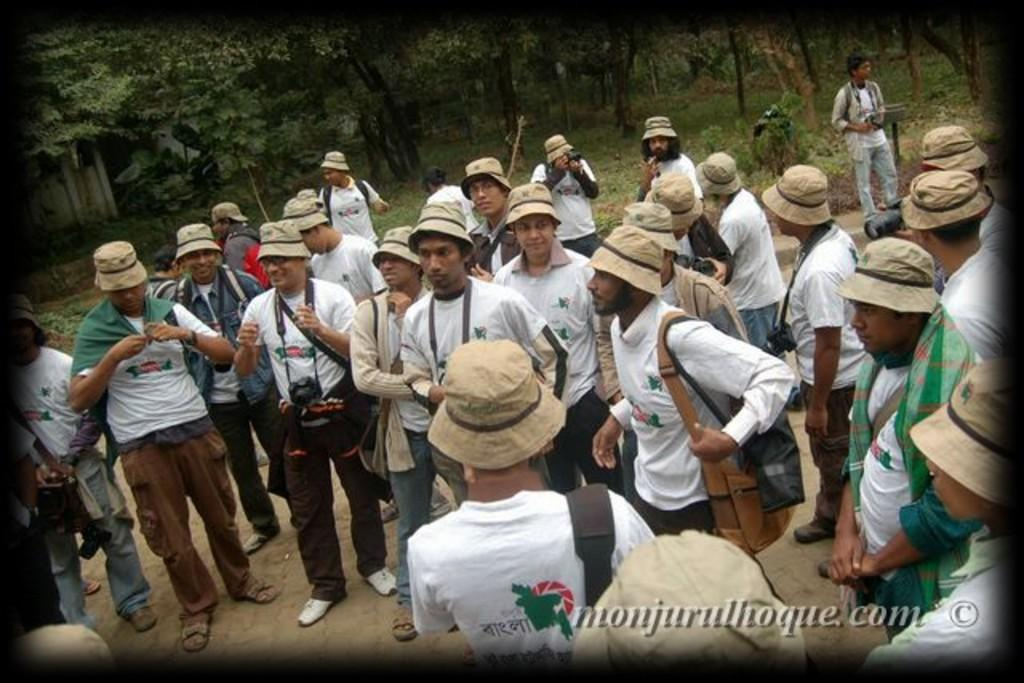Who or what can be seen in the image? There are people in the image. What are the people holding or wearing in their hands? The people are wearing and holding objects in their hands. Where are the people standing in the image? The people are standing on a path. What can be seen in the background of the image? There are trees and an object in the background of the image. What type of lettuce can be seen growing on the path in the image? There is no lettuce present in the image; the people are standing on a path with trees and an object in the background. 